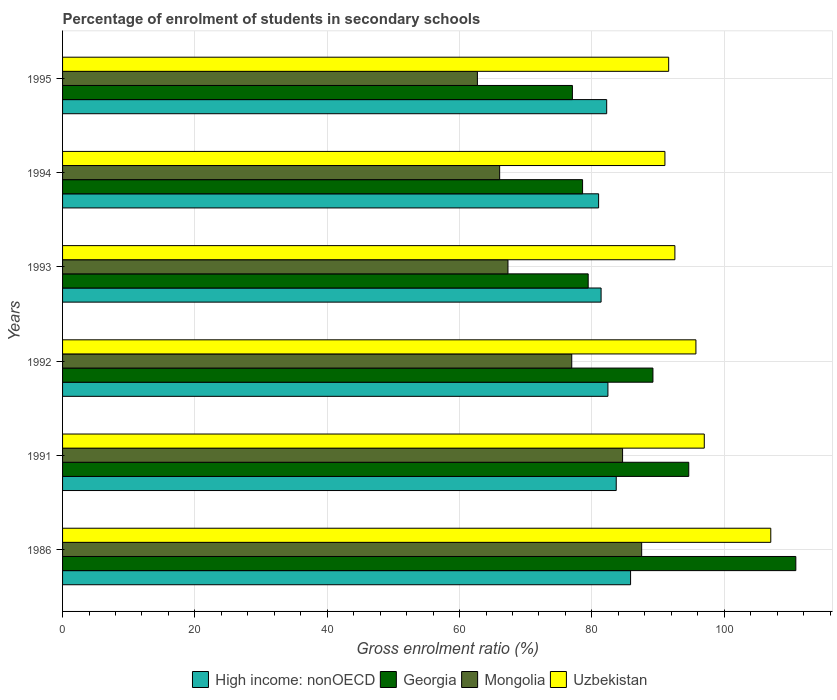How many groups of bars are there?
Provide a short and direct response. 6. Are the number of bars on each tick of the Y-axis equal?
Make the answer very short. Yes. How many bars are there on the 6th tick from the top?
Your answer should be compact. 4. What is the label of the 3rd group of bars from the top?
Make the answer very short. 1993. In how many cases, is the number of bars for a given year not equal to the number of legend labels?
Your response must be concise. 0. What is the percentage of students enrolled in secondary schools in Mongolia in 1995?
Give a very brief answer. 62.7. Across all years, what is the maximum percentage of students enrolled in secondary schools in High income: nonOECD?
Provide a short and direct response. 85.84. Across all years, what is the minimum percentage of students enrolled in secondary schools in High income: nonOECD?
Offer a terse response. 81.01. In which year was the percentage of students enrolled in secondary schools in Uzbekistan minimum?
Make the answer very short. 1994. What is the total percentage of students enrolled in secondary schools in Uzbekistan in the graph?
Make the answer very short. 574.92. What is the difference between the percentage of students enrolled in secondary schools in Georgia in 1992 and that in 1993?
Offer a very short reply. 9.79. What is the difference between the percentage of students enrolled in secondary schools in Uzbekistan in 1993 and the percentage of students enrolled in secondary schools in Mongolia in 1994?
Offer a terse response. 26.48. What is the average percentage of students enrolled in secondary schools in Uzbekistan per year?
Your answer should be very brief. 95.82. In the year 1992, what is the difference between the percentage of students enrolled in secondary schools in High income: nonOECD and percentage of students enrolled in secondary schools in Uzbekistan?
Provide a short and direct response. -13.3. In how many years, is the percentage of students enrolled in secondary schools in High income: nonOECD greater than 64 %?
Make the answer very short. 6. What is the ratio of the percentage of students enrolled in secondary schools in Georgia in 1992 to that in 1993?
Offer a terse response. 1.12. Is the percentage of students enrolled in secondary schools in Uzbekistan in 1991 less than that in 1995?
Give a very brief answer. No. What is the difference between the highest and the second highest percentage of students enrolled in secondary schools in High income: nonOECD?
Make the answer very short. 2.17. What is the difference between the highest and the lowest percentage of students enrolled in secondary schools in High income: nonOECD?
Offer a very short reply. 4.83. In how many years, is the percentage of students enrolled in secondary schools in Uzbekistan greater than the average percentage of students enrolled in secondary schools in Uzbekistan taken over all years?
Offer a very short reply. 2. Is the sum of the percentage of students enrolled in secondary schools in Uzbekistan in 1986 and 1995 greater than the maximum percentage of students enrolled in secondary schools in Georgia across all years?
Keep it short and to the point. Yes. What does the 4th bar from the top in 1993 represents?
Keep it short and to the point. High income: nonOECD. What does the 1st bar from the bottom in 1986 represents?
Your answer should be compact. High income: nonOECD. Is it the case that in every year, the sum of the percentage of students enrolled in secondary schools in High income: nonOECD and percentage of students enrolled in secondary schools in Mongolia is greater than the percentage of students enrolled in secondary schools in Uzbekistan?
Your response must be concise. Yes. Are the values on the major ticks of X-axis written in scientific E-notation?
Make the answer very short. No. Does the graph contain any zero values?
Offer a terse response. No. Does the graph contain grids?
Your answer should be very brief. Yes. Where does the legend appear in the graph?
Provide a succinct answer. Bottom center. What is the title of the graph?
Your answer should be very brief. Percentage of enrolment of students in secondary schools. Does "Suriname" appear as one of the legend labels in the graph?
Your answer should be compact. No. What is the label or title of the Y-axis?
Keep it short and to the point. Years. What is the Gross enrolment ratio (%) of High income: nonOECD in 1986?
Offer a terse response. 85.84. What is the Gross enrolment ratio (%) in Georgia in 1986?
Keep it short and to the point. 110.82. What is the Gross enrolment ratio (%) of Mongolia in 1986?
Keep it short and to the point. 87.52. What is the Gross enrolment ratio (%) in Uzbekistan in 1986?
Your response must be concise. 107.03. What is the Gross enrolment ratio (%) in High income: nonOECD in 1991?
Offer a very short reply. 83.68. What is the Gross enrolment ratio (%) of Georgia in 1991?
Your answer should be very brief. 94.64. What is the Gross enrolment ratio (%) of Mongolia in 1991?
Provide a short and direct response. 84.64. What is the Gross enrolment ratio (%) of Uzbekistan in 1991?
Give a very brief answer. 96.98. What is the Gross enrolment ratio (%) of High income: nonOECD in 1992?
Your answer should be very brief. 82.42. What is the Gross enrolment ratio (%) in Georgia in 1992?
Your answer should be compact. 89.22. What is the Gross enrolment ratio (%) of Mongolia in 1992?
Make the answer very short. 76.95. What is the Gross enrolment ratio (%) of Uzbekistan in 1992?
Make the answer very short. 95.72. What is the Gross enrolment ratio (%) of High income: nonOECD in 1993?
Provide a succinct answer. 81.39. What is the Gross enrolment ratio (%) in Georgia in 1993?
Your answer should be very brief. 79.44. What is the Gross enrolment ratio (%) of Mongolia in 1993?
Provide a short and direct response. 67.32. What is the Gross enrolment ratio (%) in Uzbekistan in 1993?
Offer a very short reply. 92.54. What is the Gross enrolment ratio (%) in High income: nonOECD in 1994?
Ensure brevity in your answer.  81.01. What is the Gross enrolment ratio (%) in Georgia in 1994?
Provide a short and direct response. 78.59. What is the Gross enrolment ratio (%) of Mongolia in 1994?
Keep it short and to the point. 66.06. What is the Gross enrolment ratio (%) in Uzbekistan in 1994?
Provide a short and direct response. 91.03. What is the Gross enrolment ratio (%) of High income: nonOECD in 1995?
Your answer should be compact. 82.23. What is the Gross enrolment ratio (%) in Georgia in 1995?
Your answer should be very brief. 77.05. What is the Gross enrolment ratio (%) in Mongolia in 1995?
Give a very brief answer. 62.7. What is the Gross enrolment ratio (%) in Uzbekistan in 1995?
Your answer should be compact. 91.6. Across all years, what is the maximum Gross enrolment ratio (%) in High income: nonOECD?
Make the answer very short. 85.84. Across all years, what is the maximum Gross enrolment ratio (%) in Georgia?
Keep it short and to the point. 110.82. Across all years, what is the maximum Gross enrolment ratio (%) of Mongolia?
Your answer should be very brief. 87.52. Across all years, what is the maximum Gross enrolment ratio (%) in Uzbekistan?
Offer a very short reply. 107.03. Across all years, what is the minimum Gross enrolment ratio (%) of High income: nonOECD?
Keep it short and to the point. 81.01. Across all years, what is the minimum Gross enrolment ratio (%) of Georgia?
Make the answer very short. 77.05. Across all years, what is the minimum Gross enrolment ratio (%) of Mongolia?
Offer a very short reply. 62.7. Across all years, what is the minimum Gross enrolment ratio (%) in Uzbekistan?
Make the answer very short. 91.03. What is the total Gross enrolment ratio (%) of High income: nonOECD in the graph?
Keep it short and to the point. 496.58. What is the total Gross enrolment ratio (%) in Georgia in the graph?
Your answer should be very brief. 529.77. What is the total Gross enrolment ratio (%) in Mongolia in the graph?
Give a very brief answer. 445.18. What is the total Gross enrolment ratio (%) in Uzbekistan in the graph?
Ensure brevity in your answer.  574.92. What is the difference between the Gross enrolment ratio (%) of High income: nonOECD in 1986 and that in 1991?
Your answer should be very brief. 2.17. What is the difference between the Gross enrolment ratio (%) in Georgia in 1986 and that in 1991?
Provide a succinct answer. 16.18. What is the difference between the Gross enrolment ratio (%) of Mongolia in 1986 and that in 1991?
Provide a short and direct response. 2.88. What is the difference between the Gross enrolment ratio (%) of Uzbekistan in 1986 and that in 1991?
Give a very brief answer. 10.05. What is the difference between the Gross enrolment ratio (%) of High income: nonOECD in 1986 and that in 1992?
Offer a terse response. 3.42. What is the difference between the Gross enrolment ratio (%) of Georgia in 1986 and that in 1992?
Offer a very short reply. 21.6. What is the difference between the Gross enrolment ratio (%) of Mongolia in 1986 and that in 1992?
Provide a succinct answer. 10.57. What is the difference between the Gross enrolment ratio (%) of Uzbekistan in 1986 and that in 1992?
Make the answer very short. 11.32. What is the difference between the Gross enrolment ratio (%) in High income: nonOECD in 1986 and that in 1993?
Your answer should be compact. 4.46. What is the difference between the Gross enrolment ratio (%) in Georgia in 1986 and that in 1993?
Provide a short and direct response. 31.38. What is the difference between the Gross enrolment ratio (%) in Mongolia in 1986 and that in 1993?
Your answer should be compact. 20.21. What is the difference between the Gross enrolment ratio (%) in Uzbekistan in 1986 and that in 1993?
Provide a succinct answer. 14.49. What is the difference between the Gross enrolment ratio (%) of High income: nonOECD in 1986 and that in 1994?
Keep it short and to the point. 4.83. What is the difference between the Gross enrolment ratio (%) in Georgia in 1986 and that in 1994?
Offer a terse response. 32.23. What is the difference between the Gross enrolment ratio (%) of Mongolia in 1986 and that in 1994?
Provide a succinct answer. 21.46. What is the difference between the Gross enrolment ratio (%) of Uzbekistan in 1986 and that in 1994?
Offer a terse response. 16. What is the difference between the Gross enrolment ratio (%) of High income: nonOECD in 1986 and that in 1995?
Provide a short and direct response. 3.61. What is the difference between the Gross enrolment ratio (%) in Georgia in 1986 and that in 1995?
Provide a short and direct response. 33.77. What is the difference between the Gross enrolment ratio (%) of Mongolia in 1986 and that in 1995?
Provide a short and direct response. 24.82. What is the difference between the Gross enrolment ratio (%) in Uzbekistan in 1986 and that in 1995?
Your answer should be compact. 15.43. What is the difference between the Gross enrolment ratio (%) in High income: nonOECD in 1991 and that in 1992?
Your answer should be very brief. 1.25. What is the difference between the Gross enrolment ratio (%) in Georgia in 1991 and that in 1992?
Ensure brevity in your answer.  5.41. What is the difference between the Gross enrolment ratio (%) in Mongolia in 1991 and that in 1992?
Provide a short and direct response. 7.68. What is the difference between the Gross enrolment ratio (%) in Uzbekistan in 1991 and that in 1992?
Provide a succinct answer. 1.26. What is the difference between the Gross enrolment ratio (%) of High income: nonOECD in 1991 and that in 1993?
Provide a succinct answer. 2.29. What is the difference between the Gross enrolment ratio (%) of Georgia in 1991 and that in 1993?
Give a very brief answer. 15.2. What is the difference between the Gross enrolment ratio (%) in Mongolia in 1991 and that in 1993?
Make the answer very short. 17.32. What is the difference between the Gross enrolment ratio (%) in Uzbekistan in 1991 and that in 1993?
Offer a terse response. 4.44. What is the difference between the Gross enrolment ratio (%) of High income: nonOECD in 1991 and that in 1994?
Keep it short and to the point. 2.66. What is the difference between the Gross enrolment ratio (%) in Georgia in 1991 and that in 1994?
Offer a terse response. 16.05. What is the difference between the Gross enrolment ratio (%) of Mongolia in 1991 and that in 1994?
Give a very brief answer. 18.58. What is the difference between the Gross enrolment ratio (%) in Uzbekistan in 1991 and that in 1994?
Keep it short and to the point. 5.95. What is the difference between the Gross enrolment ratio (%) in High income: nonOECD in 1991 and that in 1995?
Make the answer very short. 1.44. What is the difference between the Gross enrolment ratio (%) in Georgia in 1991 and that in 1995?
Make the answer very short. 17.58. What is the difference between the Gross enrolment ratio (%) in Mongolia in 1991 and that in 1995?
Your response must be concise. 21.94. What is the difference between the Gross enrolment ratio (%) of Uzbekistan in 1991 and that in 1995?
Your answer should be compact. 5.38. What is the difference between the Gross enrolment ratio (%) in High income: nonOECD in 1992 and that in 1993?
Provide a short and direct response. 1.03. What is the difference between the Gross enrolment ratio (%) in Georgia in 1992 and that in 1993?
Offer a very short reply. 9.79. What is the difference between the Gross enrolment ratio (%) in Mongolia in 1992 and that in 1993?
Give a very brief answer. 9.64. What is the difference between the Gross enrolment ratio (%) of Uzbekistan in 1992 and that in 1993?
Your answer should be very brief. 3.18. What is the difference between the Gross enrolment ratio (%) in High income: nonOECD in 1992 and that in 1994?
Your response must be concise. 1.41. What is the difference between the Gross enrolment ratio (%) of Georgia in 1992 and that in 1994?
Give a very brief answer. 10.63. What is the difference between the Gross enrolment ratio (%) in Mongolia in 1992 and that in 1994?
Provide a succinct answer. 10.89. What is the difference between the Gross enrolment ratio (%) in Uzbekistan in 1992 and that in 1994?
Offer a terse response. 4.69. What is the difference between the Gross enrolment ratio (%) in High income: nonOECD in 1992 and that in 1995?
Your answer should be very brief. 0.19. What is the difference between the Gross enrolment ratio (%) of Georgia in 1992 and that in 1995?
Your response must be concise. 12.17. What is the difference between the Gross enrolment ratio (%) of Mongolia in 1992 and that in 1995?
Offer a very short reply. 14.26. What is the difference between the Gross enrolment ratio (%) in Uzbekistan in 1992 and that in 1995?
Give a very brief answer. 4.12. What is the difference between the Gross enrolment ratio (%) in High income: nonOECD in 1993 and that in 1994?
Offer a terse response. 0.37. What is the difference between the Gross enrolment ratio (%) of Georgia in 1993 and that in 1994?
Give a very brief answer. 0.85. What is the difference between the Gross enrolment ratio (%) in Mongolia in 1993 and that in 1994?
Your answer should be very brief. 1.26. What is the difference between the Gross enrolment ratio (%) of Uzbekistan in 1993 and that in 1994?
Offer a very short reply. 1.51. What is the difference between the Gross enrolment ratio (%) of High income: nonOECD in 1993 and that in 1995?
Your answer should be very brief. -0.85. What is the difference between the Gross enrolment ratio (%) of Georgia in 1993 and that in 1995?
Ensure brevity in your answer.  2.38. What is the difference between the Gross enrolment ratio (%) in Mongolia in 1993 and that in 1995?
Keep it short and to the point. 4.62. What is the difference between the Gross enrolment ratio (%) in Uzbekistan in 1993 and that in 1995?
Make the answer very short. 0.94. What is the difference between the Gross enrolment ratio (%) in High income: nonOECD in 1994 and that in 1995?
Your answer should be very brief. -1.22. What is the difference between the Gross enrolment ratio (%) in Georgia in 1994 and that in 1995?
Ensure brevity in your answer.  1.54. What is the difference between the Gross enrolment ratio (%) in Mongolia in 1994 and that in 1995?
Make the answer very short. 3.36. What is the difference between the Gross enrolment ratio (%) of Uzbekistan in 1994 and that in 1995?
Offer a very short reply. -0.57. What is the difference between the Gross enrolment ratio (%) in High income: nonOECD in 1986 and the Gross enrolment ratio (%) in Georgia in 1991?
Offer a terse response. -8.79. What is the difference between the Gross enrolment ratio (%) of High income: nonOECD in 1986 and the Gross enrolment ratio (%) of Mongolia in 1991?
Your answer should be very brief. 1.21. What is the difference between the Gross enrolment ratio (%) in High income: nonOECD in 1986 and the Gross enrolment ratio (%) in Uzbekistan in 1991?
Offer a very short reply. -11.14. What is the difference between the Gross enrolment ratio (%) in Georgia in 1986 and the Gross enrolment ratio (%) in Mongolia in 1991?
Give a very brief answer. 26.18. What is the difference between the Gross enrolment ratio (%) of Georgia in 1986 and the Gross enrolment ratio (%) of Uzbekistan in 1991?
Offer a very short reply. 13.84. What is the difference between the Gross enrolment ratio (%) in Mongolia in 1986 and the Gross enrolment ratio (%) in Uzbekistan in 1991?
Provide a succinct answer. -9.46. What is the difference between the Gross enrolment ratio (%) in High income: nonOECD in 1986 and the Gross enrolment ratio (%) in Georgia in 1992?
Give a very brief answer. -3.38. What is the difference between the Gross enrolment ratio (%) in High income: nonOECD in 1986 and the Gross enrolment ratio (%) in Mongolia in 1992?
Offer a very short reply. 8.89. What is the difference between the Gross enrolment ratio (%) in High income: nonOECD in 1986 and the Gross enrolment ratio (%) in Uzbekistan in 1992?
Provide a short and direct response. -9.88. What is the difference between the Gross enrolment ratio (%) of Georgia in 1986 and the Gross enrolment ratio (%) of Mongolia in 1992?
Offer a terse response. 33.87. What is the difference between the Gross enrolment ratio (%) in Georgia in 1986 and the Gross enrolment ratio (%) in Uzbekistan in 1992?
Your answer should be compact. 15.1. What is the difference between the Gross enrolment ratio (%) in Mongolia in 1986 and the Gross enrolment ratio (%) in Uzbekistan in 1992?
Keep it short and to the point. -8.2. What is the difference between the Gross enrolment ratio (%) in High income: nonOECD in 1986 and the Gross enrolment ratio (%) in Georgia in 1993?
Give a very brief answer. 6.41. What is the difference between the Gross enrolment ratio (%) of High income: nonOECD in 1986 and the Gross enrolment ratio (%) of Mongolia in 1993?
Your answer should be compact. 18.53. What is the difference between the Gross enrolment ratio (%) of High income: nonOECD in 1986 and the Gross enrolment ratio (%) of Uzbekistan in 1993?
Keep it short and to the point. -6.7. What is the difference between the Gross enrolment ratio (%) of Georgia in 1986 and the Gross enrolment ratio (%) of Mongolia in 1993?
Give a very brief answer. 43.5. What is the difference between the Gross enrolment ratio (%) in Georgia in 1986 and the Gross enrolment ratio (%) in Uzbekistan in 1993?
Your answer should be very brief. 18.28. What is the difference between the Gross enrolment ratio (%) of Mongolia in 1986 and the Gross enrolment ratio (%) of Uzbekistan in 1993?
Keep it short and to the point. -5.02. What is the difference between the Gross enrolment ratio (%) of High income: nonOECD in 1986 and the Gross enrolment ratio (%) of Georgia in 1994?
Make the answer very short. 7.25. What is the difference between the Gross enrolment ratio (%) of High income: nonOECD in 1986 and the Gross enrolment ratio (%) of Mongolia in 1994?
Your response must be concise. 19.79. What is the difference between the Gross enrolment ratio (%) in High income: nonOECD in 1986 and the Gross enrolment ratio (%) in Uzbekistan in 1994?
Keep it short and to the point. -5.19. What is the difference between the Gross enrolment ratio (%) of Georgia in 1986 and the Gross enrolment ratio (%) of Mongolia in 1994?
Ensure brevity in your answer.  44.76. What is the difference between the Gross enrolment ratio (%) in Georgia in 1986 and the Gross enrolment ratio (%) in Uzbekistan in 1994?
Provide a succinct answer. 19.78. What is the difference between the Gross enrolment ratio (%) in Mongolia in 1986 and the Gross enrolment ratio (%) in Uzbekistan in 1994?
Your answer should be very brief. -3.51. What is the difference between the Gross enrolment ratio (%) in High income: nonOECD in 1986 and the Gross enrolment ratio (%) in Georgia in 1995?
Your response must be concise. 8.79. What is the difference between the Gross enrolment ratio (%) in High income: nonOECD in 1986 and the Gross enrolment ratio (%) in Mongolia in 1995?
Make the answer very short. 23.15. What is the difference between the Gross enrolment ratio (%) of High income: nonOECD in 1986 and the Gross enrolment ratio (%) of Uzbekistan in 1995?
Ensure brevity in your answer.  -5.76. What is the difference between the Gross enrolment ratio (%) of Georgia in 1986 and the Gross enrolment ratio (%) of Mongolia in 1995?
Give a very brief answer. 48.12. What is the difference between the Gross enrolment ratio (%) of Georgia in 1986 and the Gross enrolment ratio (%) of Uzbekistan in 1995?
Your response must be concise. 19.22. What is the difference between the Gross enrolment ratio (%) in Mongolia in 1986 and the Gross enrolment ratio (%) in Uzbekistan in 1995?
Offer a very short reply. -4.08. What is the difference between the Gross enrolment ratio (%) of High income: nonOECD in 1991 and the Gross enrolment ratio (%) of Georgia in 1992?
Offer a very short reply. -5.55. What is the difference between the Gross enrolment ratio (%) in High income: nonOECD in 1991 and the Gross enrolment ratio (%) in Mongolia in 1992?
Make the answer very short. 6.72. What is the difference between the Gross enrolment ratio (%) in High income: nonOECD in 1991 and the Gross enrolment ratio (%) in Uzbekistan in 1992?
Make the answer very short. -12.04. What is the difference between the Gross enrolment ratio (%) in Georgia in 1991 and the Gross enrolment ratio (%) in Mongolia in 1992?
Keep it short and to the point. 17.69. What is the difference between the Gross enrolment ratio (%) in Georgia in 1991 and the Gross enrolment ratio (%) in Uzbekistan in 1992?
Ensure brevity in your answer.  -1.08. What is the difference between the Gross enrolment ratio (%) in Mongolia in 1991 and the Gross enrolment ratio (%) in Uzbekistan in 1992?
Ensure brevity in your answer.  -11.08. What is the difference between the Gross enrolment ratio (%) of High income: nonOECD in 1991 and the Gross enrolment ratio (%) of Georgia in 1993?
Your response must be concise. 4.24. What is the difference between the Gross enrolment ratio (%) in High income: nonOECD in 1991 and the Gross enrolment ratio (%) in Mongolia in 1993?
Offer a very short reply. 16.36. What is the difference between the Gross enrolment ratio (%) of High income: nonOECD in 1991 and the Gross enrolment ratio (%) of Uzbekistan in 1993?
Offer a terse response. -8.87. What is the difference between the Gross enrolment ratio (%) in Georgia in 1991 and the Gross enrolment ratio (%) in Mongolia in 1993?
Ensure brevity in your answer.  27.32. What is the difference between the Gross enrolment ratio (%) of Georgia in 1991 and the Gross enrolment ratio (%) of Uzbekistan in 1993?
Make the answer very short. 2.1. What is the difference between the Gross enrolment ratio (%) in Mongolia in 1991 and the Gross enrolment ratio (%) in Uzbekistan in 1993?
Offer a very short reply. -7.9. What is the difference between the Gross enrolment ratio (%) of High income: nonOECD in 1991 and the Gross enrolment ratio (%) of Georgia in 1994?
Your answer should be compact. 5.08. What is the difference between the Gross enrolment ratio (%) of High income: nonOECD in 1991 and the Gross enrolment ratio (%) of Mongolia in 1994?
Provide a short and direct response. 17.62. What is the difference between the Gross enrolment ratio (%) of High income: nonOECD in 1991 and the Gross enrolment ratio (%) of Uzbekistan in 1994?
Provide a succinct answer. -7.36. What is the difference between the Gross enrolment ratio (%) in Georgia in 1991 and the Gross enrolment ratio (%) in Mongolia in 1994?
Offer a very short reply. 28.58. What is the difference between the Gross enrolment ratio (%) in Georgia in 1991 and the Gross enrolment ratio (%) in Uzbekistan in 1994?
Your response must be concise. 3.6. What is the difference between the Gross enrolment ratio (%) in Mongolia in 1991 and the Gross enrolment ratio (%) in Uzbekistan in 1994?
Ensure brevity in your answer.  -6.4. What is the difference between the Gross enrolment ratio (%) in High income: nonOECD in 1991 and the Gross enrolment ratio (%) in Georgia in 1995?
Your response must be concise. 6.62. What is the difference between the Gross enrolment ratio (%) in High income: nonOECD in 1991 and the Gross enrolment ratio (%) in Mongolia in 1995?
Make the answer very short. 20.98. What is the difference between the Gross enrolment ratio (%) of High income: nonOECD in 1991 and the Gross enrolment ratio (%) of Uzbekistan in 1995?
Your answer should be very brief. -7.93. What is the difference between the Gross enrolment ratio (%) of Georgia in 1991 and the Gross enrolment ratio (%) of Mongolia in 1995?
Your response must be concise. 31.94. What is the difference between the Gross enrolment ratio (%) of Georgia in 1991 and the Gross enrolment ratio (%) of Uzbekistan in 1995?
Offer a terse response. 3.04. What is the difference between the Gross enrolment ratio (%) in Mongolia in 1991 and the Gross enrolment ratio (%) in Uzbekistan in 1995?
Offer a very short reply. -6.97. What is the difference between the Gross enrolment ratio (%) of High income: nonOECD in 1992 and the Gross enrolment ratio (%) of Georgia in 1993?
Your answer should be compact. 2.98. What is the difference between the Gross enrolment ratio (%) of High income: nonOECD in 1992 and the Gross enrolment ratio (%) of Mongolia in 1993?
Your answer should be compact. 15.11. What is the difference between the Gross enrolment ratio (%) in High income: nonOECD in 1992 and the Gross enrolment ratio (%) in Uzbekistan in 1993?
Offer a terse response. -10.12. What is the difference between the Gross enrolment ratio (%) in Georgia in 1992 and the Gross enrolment ratio (%) in Mongolia in 1993?
Offer a terse response. 21.91. What is the difference between the Gross enrolment ratio (%) in Georgia in 1992 and the Gross enrolment ratio (%) in Uzbekistan in 1993?
Your response must be concise. -3.32. What is the difference between the Gross enrolment ratio (%) in Mongolia in 1992 and the Gross enrolment ratio (%) in Uzbekistan in 1993?
Provide a succinct answer. -15.59. What is the difference between the Gross enrolment ratio (%) of High income: nonOECD in 1992 and the Gross enrolment ratio (%) of Georgia in 1994?
Your response must be concise. 3.83. What is the difference between the Gross enrolment ratio (%) of High income: nonOECD in 1992 and the Gross enrolment ratio (%) of Mongolia in 1994?
Provide a short and direct response. 16.36. What is the difference between the Gross enrolment ratio (%) in High income: nonOECD in 1992 and the Gross enrolment ratio (%) in Uzbekistan in 1994?
Your answer should be very brief. -8.61. What is the difference between the Gross enrolment ratio (%) of Georgia in 1992 and the Gross enrolment ratio (%) of Mongolia in 1994?
Offer a very short reply. 23.16. What is the difference between the Gross enrolment ratio (%) in Georgia in 1992 and the Gross enrolment ratio (%) in Uzbekistan in 1994?
Make the answer very short. -1.81. What is the difference between the Gross enrolment ratio (%) in Mongolia in 1992 and the Gross enrolment ratio (%) in Uzbekistan in 1994?
Your answer should be compact. -14.08. What is the difference between the Gross enrolment ratio (%) in High income: nonOECD in 1992 and the Gross enrolment ratio (%) in Georgia in 1995?
Your response must be concise. 5.37. What is the difference between the Gross enrolment ratio (%) in High income: nonOECD in 1992 and the Gross enrolment ratio (%) in Mongolia in 1995?
Provide a short and direct response. 19.72. What is the difference between the Gross enrolment ratio (%) of High income: nonOECD in 1992 and the Gross enrolment ratio (%) of Uzbekistan in 1995?
Provide a succinct answer. -9.18. What is the difference between the Gross enrolment ratio (%) of Georgia in 1992 and the Gross enrolment ratio (%) of Mongolia in 1995?
Offer a very short reply. 26.53. What is the difference between the Gross enrolment ratio (%) of Georgia in 1992 and the Gross enrolment ratio (%) of Uzbekistan in 1995?
Make the answer very short. -2.38. What is the difference between the Gross enrolment ratio (%) in Mongolia in 1992 and the Gross enrolment ratio (%) in Uzbekistan in 1995?
Your answer should be compact. -14.65. What is the difference between the Gross enrolment ratio (%) of High income: nonOECD in 1993 and the Gross enrolment ratio (%) of Georgia in 1994?
Offer a very short reply. 2.8. What is the difference between the Gross enrolment ratio (%) of High income: nonOECD in 1993 and the Gross enrolment ratio (%) of Mongolia in 1994?
Offer a terse response. 15.33. What is the difference between the Gross enrolment ratio (%) of High income: nonOECD in 1993 and the Gross enrolment ratio (%) of Uzbekistan in 1994?
Offer a terse response. -9.65. What is the difference between the Gross enrolment ratio (%) of Georgia in 1993 and the Gross enrolment ratio (%) of Mongolia in 1994?
Make the answer very short. 13.38. What is the difference between the Gross enrolment ratio (%) in Georgia in 1993 and the Gross enrolment ratio (%) in Uzbekistan in 1994?
Offer a very short reply. -11.6. What is the difference between the Gross enrolment ratio (%) of Mongolia in 1993 and the Gross enrolment ratio (%) of Uzbekistan in 1994?
Offer a very short reply. -23.72. What is the difference between the Gross enrolment ratio (%) of High income: nonOECD in 1993 and the Gross enrolment ratio (%) of Georgia in 1995?
Offer a very short reply. 4.33. What is the difference between the Gross enrolment ratio (%) of High income: nonOECD in 1993 and the Gross enrolment ratio (%) of Mongolia in 1995?
Your response must be concise. 18.69. What is the difference between the Gross enrolment ratio (%) in High income: nonOECD in 1993 and the Gross enrolment ratio (%) in Uzbekistan in 1995?
Keep it short and to the point. -10.21. What is the difference between the Gross enrolment ratio (%) in Georgia in 1993 and the Gross enrolment ratio (%) in Mongolia in 1995?
Your answer should be compact. 16.74. What is the difference between the Gross enrolment ratio (%) of Georgia in 1993 and the Gross enrolment ratio (%) of Uzbekistan in 1995?
Ensure brevity in your answer.  -12.16. What is the difference between the Gross enrolment ratio (%) in Mongolia in 1993 and the Gross enrolment ratio (%) in Uzbekistan in 1995?
Provide a succinct answer. -24.29. What is the difference between the Gross enrolment ratio (%) in High income: nonOECD in 1994 and the Gross enrolment ratio (%) in Georgia in 1995?
Give a very brief answer. 3.96. What is the difference between the Gross enrolment ratio (%) of High income: nonOECD in 1994 and the Gross enrolment ratio (%) of Mongolia in 1995?
Your answer should be very brief. 18.32. What is the difference between the Gross enrolment ratio (%) of High income: nonOECD in 1994 and the Gross enrolment ratio (%) of Uzbekistan in 1995?
Provide a short and direct response. -10.59. What is the difference between the Gross enrolment ratio (%) in Georgia in 1994 and the Gross enrolment ratio (%) in Mongolia in 1995?
Provide a succinct answer. 15.89. What is the difference between the Gross enrolment ratio (%) in Georgia in 1994 and the Gross enrolment ratio (%) in Uzbekistan in 1995?
Provide a short and direct response. -13.01. What is the difference between the Gross enrolment ratio (%) of Mongolia in 1994 and the Gross enrolment ratio (%) of Uzbekistan in 1995?
Offer a very short reply. -25.54. What is the average Gross enrolment ratio (%) in High income: nonOECD per year?
Your answer should be very brief. 82.76. What is the average Gross enrolment ratio (%) of Georgia per year?
Keep it short and to the point. 88.29. What is the average Gross enrolment ratio (%) of Mongolia per year?
Give a very brief answer. 74.2. What is the average Gross enrolment ratio (%) in Uzbekistan per year?
Your answer should be very brief. 95.82. In the year 1986, what is the difference between the Gross enrolment ratio (%) of High income: nonOECD and Gross enrolment ratio (%) of Georgia?
Keep it short and to the point. -24.98. In the year 1986, what is the difference between the Gross enrolment ratio (%) of High income: nonOECD and Gross enrolment ratio (%) of Mongolia?
Your answer should be compact. -1.68. In the year 1986, what is the difference between the Gross enrolment ratio (%) in High income: nonOECD and Gross enrolment ratio (%) in Uzbekistan?
Offer a very short reply. -21.19. In the year 1986, what is the difference between the Gross enrolment ratio (%) in Georgia and Gross enrolment ratio (%) in Mongolia?
Your response must be concise. 23.3. In the year 1986, what is the difference between the Gross enrolment ratio (%) in Georgia and Gross enrolment ratio (%) in Uzbekistan?
Keep it short and to the point. 3.78. In the year 1986, what is the difference between the Gross enrolment ratio (%) in Mongolia and Gross enrolment ratio (%) in Uzbekistan?
Provide a succinct answer. -19.51. In the year 1991, what is the difference between the Gross enrolment ratio (%) in High income: nonOECD and Gross enrolment ratio (%) in Georgia?
Your answer should be compact. -10.96. In the year 1991, what is the difference between the Gross enrolment ratio (%) of High income: nonOECD and Gross enrolment ratio (%) of Mongolia?
Your response must be concise. -0.96. In the year 1991, what is the difference between the Gross enrolment ratio (%) of High income: nonOECD and Gross enrolment ratio (%) of Uzbekistan?
Ensure brevity in your answer.  -13.31. In the year 1991, what is the difference between the Gross enrolment ratio (%) of Georgia and Gross enrolment ratio (%) of Mongolia?
Provide a succinct answer. 10. In the year 1991, what is the difference between the Gross enrolment ratio (%) of Georgia and Gross enrolment ratio (%) of Uzbekistan?
Provide a succinct answer. -2.35. In the year 1991, what is the difference between the Gross enrolment ratio (%) of Mongolia and Gross enrolment ratio (%) of Uzbekistan?
Make the answer very short. -12.35. In the year 1992, what is the difference between the Gross enrolment ratio (%) in High income: nonOECD and Gross enrolment ratio (%) in Georgia?
Your response must be concise. -6.8. In the year 1992, what is the difference between the Gross enrolment ratio (%) of High income: nonOECD and Gross enrolment ratio (%) of Mongolia?
Ensure brevity in your answer.  5.47. In the year 1992, what is the difference between the Gross enrolment ratio (%) of High income: nonOECD and Gross enrolment ratio (%) of Uzbekistan?
Offer a terse response. -13.3. In the year 1992, what is the difference between the Gross enrolment ratio (%) in Georgia and Gross enrolment ratio (%) in Mongolia?
Offer a very short reply. 12.27. In the year 1992, what is the difference between the Gross enrolment ratio (%) of Georgia and Gross enrolment ratio (%) of Uzbekistan?
Keep it short and to the point. -6.5. In the year 1992, what is the difference between the Gross enrolment ratio (%) of Mongolia and Gross enrolment ratio (%) of Uzbekistan?
Your answer should be compact. -18.77. In the year 1993, what is the difference between the Gross enrolment ratio (%) of High income: nonOECD and Gross enrolment ratio (%) of Georgia?
Offer a very short reply. 1.95. In the year 1993, what is the difference between the Gross enrolment ratio (%) of High income: nonOECD and Gross enrolment ratio (%) of Mongolia?
Your answer should be very brief. 14.07. In the year 1993, what is the difference between the Gross enrolment ratio (%) in High income: nonOECD and Gross enrolment ratio (%) in Uzbekistan?
Your answer should be compact. -11.15. In the year 1993, what is the difference between the Gross enrolment ratio (%) of Georgia and Gross enrolment ratio (%) of Mongolia?
Keep it short and to the point. 12.12. In the year 1993, what is the difference between the Gross enrolment ratio (%) of Georgia and Gross enrolment ratio (%) of Uzbekistan?
Provide a succinct answer. -13.1. In the year 1993, what is the difference between the Gross enrolment ratio (%) of Mongolia and Gross enrolment ratio (%) of Uzbekistan?
Ensure brevity in your answer.  -25.23. In the year 1994, what is the difference between the Gross enrolment ratio (%) in High income: nonOECD and Gross enrolment ratio (%) in Georgia?
Offer a very short reply. 2.42. In the year 1994, what is the difference between the Gross enrolment ratio (%) of High income: nonOECD and Gross enrolment ratio (%) of Mongolia?
Provide a succinct answer. 14.95. In the year 1994, what is the difference between the Gross enrolment ratio (%) of High income: nonOECD and Gross enrolment ratio (%) of Uzbekistan?
Make the answer very short. -10.02. In the year 1994, what is the difference between the Gross enrolment ratio (%) in Georgia and Gross enrolment ratio (%) in Mongolia?
Offer a terse response. 12.53. In the year 1994, what is the difference between the Gross enrolment ratio (%) of Georgia and Gross enrolment ratio (%) of Uzbekistan?
Offer a very short reply. -12.44. In the year 1994, what is the difference between the Gross enrolment ratio (%) in Mongolia and Gross enrolment ratio (%) in Uzbekistan?
Offer a terse response. -24.98. In the year 1995, what is the difference between the Gross enrolment ratio (%) in High income: nonOECD and Gross enrolment ratio (%) in Georgia?
Offer a terse response. 5.18. In the year 1995, what is the difference between the Gross enrolment ratio (%) of High income: nonOECD and Gross enrolment ratio (%) of Mongolia?
Provide a succinct answer. 19.54. In the year 1995, what is the difference between the Gross enrolment ratio (%) in High income: nonOECD and Gross enrolment ratio (%) in Uzbekistan?
Offer a very short reply. -9.37. In the year 1995, what is the difference between the Gross enrolment ratio (%) in Georgia and Gross enrolment ratio (%) in Mongolia?
Ensure brevity in your answer.  14.36. In the year 1995, what is the difference between the Gross enrolment ratio (%) in Georgia and Gross enrolment ratio (%) in Uzbekistan?
Your answer should be compact. -14.55. In the year 1995, what is the difference between the Gross enrolment ratio (%) in Mongolia and Gross enrolment ratio (%) in Uzbekistan?
Keep it short and to the point. -28.91. What is the ratio of the Gross enrolment ratio (%) of High income: nonOECD in 1986 to that in 1991?
Provide a succinct answer. 1.03. What is the ratio of the Gross enrolment ratio (%) in Georgia in 1986 to that in 1991?
Your answer should be very brief. 1.17. What is the ratio of the Gross enrolment ratio (%) in Mongolia in 1986 to that in 1991?
Your response must be concise. 1.03. What is the ratio of the Gross enrolment ratio (%) of Uzbekistan in 1986 to that in 1991?
Your response must be concise. 1.1. What is the ratio of the Gross enrolment ratio (%) of High income: nonOECD in 1986 to that in 1992?
Your response must be concise. 1.04. What is the ratio of the Gross enrolment ratio (%) in Georgia in 1986 to that in 1992?
Provide a succinct answer. 1.24. What is the ratio of the Gross enrolment ratio (%) of Mongolia in 1986 to that in 1992?
Your answer should be very brief. 1.14. What is the ratio of the Gross enrolment ratio (%) of Uzbekistan in 1986 to that in 1992?
Keep it short and to the point. 1.12. What is the ratio of the Gross enrolment ratio (%) in High income: nonOECD in 1986 to that in 1993?
Ensure brevity in your answer.  1.05. What is the ratio of the Gross enrolment ratio (%) in Georgia in 1986 to that in 1993?
Offer a terse response. 1.4. What is the ratio of the Gross enrolment ratio (%) in Mongolia in 1986 to that in 1993?
Provide a short and direct response. 1.3. What is the ratio of the Gross enrolment ratio (%) in Uzbekistan in 1986 to that in 1993?
Make the answer very short. 1.16. What is the ratio of the Gross enrolment ratio (%) of High income: nonOECD in 1986 to that in 1994?
Offer a very short reply. 1.06. What is the ratio of the Gross enrolment ratio (%) in Georgia in 1986 to that in 1994?
Give a very brief answer. 1.41. What is the ratio of the Gross enrolment ratio (%) in Mongolia in 1986 to that in 1994?
Provide a succinct answer. 1.32. What is the ratio of the Gross enrolment ratio (%) of Uzbekistan in 1986 to that in 1994?
Your response must be concise. 1.18. What is the ratio of the Gross enrolment ratio (%) of High income: nonOECD in 1986 to that in 1995?
Offer a very short reply. 1.04. What is the ratio of the Gross enrolment ratio (%) in Georgia in 1986 to that in 1995?
Offer a terse response. 1.44. What is the ratio of the Gross enrolment ratio (%) in Mongolia in 1986 to that in 1995?
Give a very brief answer. 1.4. What is the ratio of the Gross enrolment ratio (%) of Uzbekistan in 1986 to that in 1995?
Offer a terse response. 1.17. What is the ratio of the Gross enrolment ratio (%) of High income: nonOECD in 1991 to that in 1992?
Make the answer very short. 1.02. What is the ratio of the Gross enrolment ratio (%) of Georgia in 1991 to that in 1992?
Make the answer very short. 1.06. What is the ratio of the Gross enrolment ratio (%) in Mongolia in 1991 to that in 1992?
Your response must be concise. 1.1. What is the ratio of the Gross enrolment ratio (%) of Uzbekistan in 1991 to that in 1992?
Provide a succinct answer. 1.01. What is the ratio of the Gross enrolment ratio (%) in High income: nonOECD in 1991 to that in 1993?
Your answer should be very brief. 1.03. What is the ratio of the Gross enrolment ratio (%) in Georgia in 1991 to that in 1993?
Give a very brief answer. 1.19. What is the ratio of the Gross enrolment ratio (%) in Mongolia in 1991 to that in 1993?
Offer a terse response. 1.26. What is the ratio of the Gross enrolment ratio (%) in Uzbekistan in 1991 to that in 1993?
Offer a terse response. 1.05. What is the ratio of the Gross enrolment ratio (%) of High income: nonOECD in 1991 to that in 1994?
Your response must be concise. 1.03. What is the ratio of the Gross enrolment ratio (%) of Georgia in 1991 to that in 1994?
Your answer should be compact. 1.2. What is the ratio of the Gross enrolment ratio (%) in Mongolia in 1991 to that in 1994?
Your answer should be compact. 1.28. What is the ratio of the Gross enrolment ratio (%) in Uzbekistan in 1991 to that in 1994?
Your answer should be very brief. 1.07. What is the ratio of the Gross enrolment ratio (%) in High income: nonOECD in 1991 to that in 1995?
Offer a terse response. 1.02. What is the ratio of the Gross enrolment ratio (%) of Georgia in 1991 to that in 1995?
Your response must be concise. 1.23. What is the ratio of the Gross enrolment ratio (%) of Mongolia in 1991 to that in 1995?
Your answer should be compact. 1.35. What is the ratio of the Gross enrolment ratio (%) in Uzbekistan in 1991 to that in 1995?
Offer a very short reply. 1.06. What is the ratio of the Gross enrolment ratio (%) in High income: nonOECD in 1992 to that in 1993?
Your answer should be compact. 1.01. What is the ratio of the Gross enrolment ratio (%) of Georgia in 1992 to that in 1993?
Make the answer very short. 1.12. What is the ratio of the Gross enrolment ratio (%) in Mongolia in 1992 to that in 1993?
Your answer should be very brief. 1.14. What is the ratio of the Gross enrolment ratio (%) of Uzbekistan in 1992 to that in 1993?
Give a very brief answer. 1.03. What is the ratio of the Gross enrolment ratio (%) of High income: nonOECD in 1992 to that in 1994?
Keep it short and to the point. 1.02. What is the ratio of the Gross enrolment ratio (%) of Georgia in 1992 to that in 1994?
Make the answer very short. 1.14. What is the ratio of the Gross enrolment ratio (%) of Mongolia in 1992 to that in 1994?
Your answer should be compact. 1.16. What is the ratio of the Gross enrolment ratio (%) in Uzbekistan in 1992 to that in 1994?
Your response must be concise. 1.05. What is the ratio of the Gross enrolment ratio (%) of Georgia in 1992 to that in 1995?
Give a very brief answer. 1.16. What is the ratio of the Gross enrolment ratio (%) in Mongolia in 1992 to that in 1995?
Your answer should be very brief. 1.23. What is the ratio of the Gross enrolment ratio (%) of Uzbekistan in 1992 to that in 1995?
Keep it short and to the point. 1.04. What is the ratio of the Gross enrolment ratio (%) in High income: nonOECD in 1993 to that in 1994?
Offer a terse response. 1. What is the ratio of the Gross enrolment ratio (%) of Georgia in 1993 to that in 1994?
Provide a succinct answer. 1.01. What is the ratio of the Gross enrolment ratio (%) of Mongolia in 1993 to that in 1994?
Provide a short and direct response. 1.02. What is the ratio of the Gross enrolment ratio (%) in Uzbekistan in 1993 to that in 1994?
Ensure brevity in your answer.  1.02. What is the ratio of the Gross enrolment ratio (%) in High income: nonOECD in 1993 to that in 1995?
Offer a very short reply. 0.99. What is the ratio of the Gross enrolment ratio (%) in Georgia in 1993 to that in 1995?
Offer a very short reply. 1.03. What is the ratio of the Gross enrolment ratio (%) of Mongolia in 1993 to that in 1995?
Provide a succinct answer. 1.07. What is the ratio of the Gross enrolment ratio (%) of Uzbekistan in 1993 to that in 1995?
Ensure brevity in your answer.  1.01. What is the ratio of the Gross enrolment ratio (%) of High income: nonOECD in 1994 to that in 1995?
Offer a terse response. 0.99. What is the ratio of the Gross enrolment ratio (%) in Georgia in 1994 to that in 1995?
Keep it short and to the point. 1.02. What is the ratio of the Gross enrolment ratio (%) of Mongolia in 1994 to that in 1995?
Offer a terse response. 1.05. What is the difference between the highest and the second highest Gross enrolment ratio (%) in High income: nonOECD?
Your answer should be compact. 2.17. What is the difference between the highest and the second highest Gross enrolment ratio (%) in Georgia?
Offer a terse response. 16.18. What is the difference between the highest and the second highest Gross enrolment ratio (%) of Mongolia?
Provide a short and direct response. 2.88. What is the difference between the highest and the second highest Gross enrolment ratio (%) in Uzbekistan?
Keep it short and to the point. 10.05. What is the difference between the highest and the lowest Gross enrolment ratio (%) in High income: nonOECD?
Your answer should be compact. 4.83. What is the difference between the highest and the lowest Gross enrolment ratio (%) in Georgia?
Offer a terse response. 33.77. What is the difference between the highest and the lowest Gross enrolment ratio (%) in Mongolia?
Your response must be concise. 24.82. What is the difference between the highest and the lowest Gross enrolment ratio (%) in Uzbekistan?
Make the answer very short. 16. 